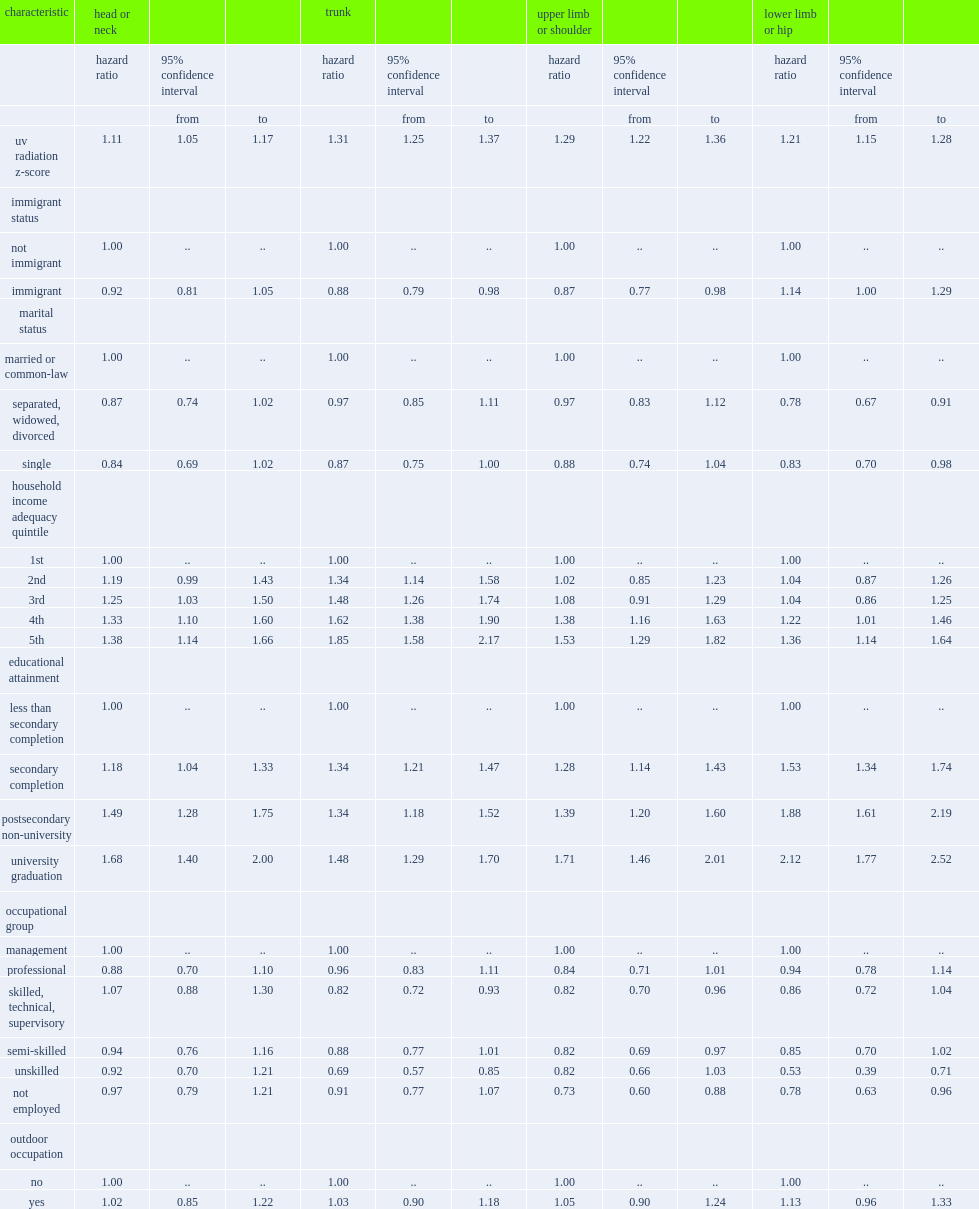What is the hr for melanoma per increase of 1 s.d. in z-score for the trunk? 1.31. 